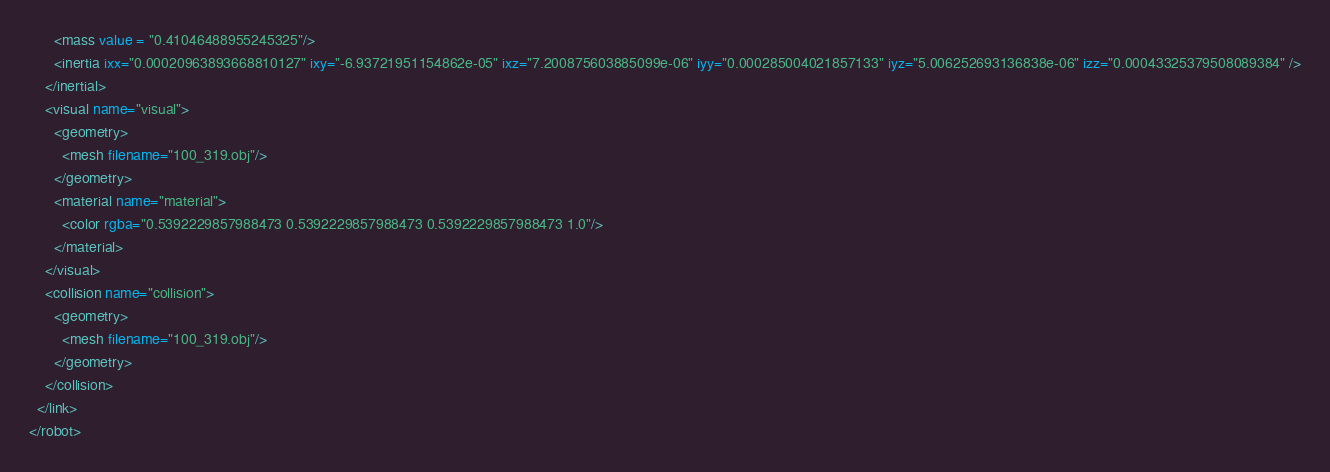<code> <loc_0><loc_0><loc_500><loc_500><_XML_>      <mass value = "0.41046488955245325"/>
      <inertia ixx="0.00020963893668810127" ixy="-6.93721951154862e-05" ixz="7.200875603885099e-06" iyy="0.000285004021857133" iyz="5.006252693136838e-06" izz="0.00043325379508089384" />
    </inertial>
    <visual name="visual">
      <geometry>
        <mesh filename="100_319.obj"/>
      </geometry>
      <material name="material">
        <color rgba="0.5392229857988473 0.5392229857988473 0.5392229857988473 1.0"/>
      </material>
    </visual>
    <collision name="collision">
      <geometry>
        <mesh filename="100_319.obj"/>
      </geometry>
    </collision>
  </link>
</robot>
</code> 